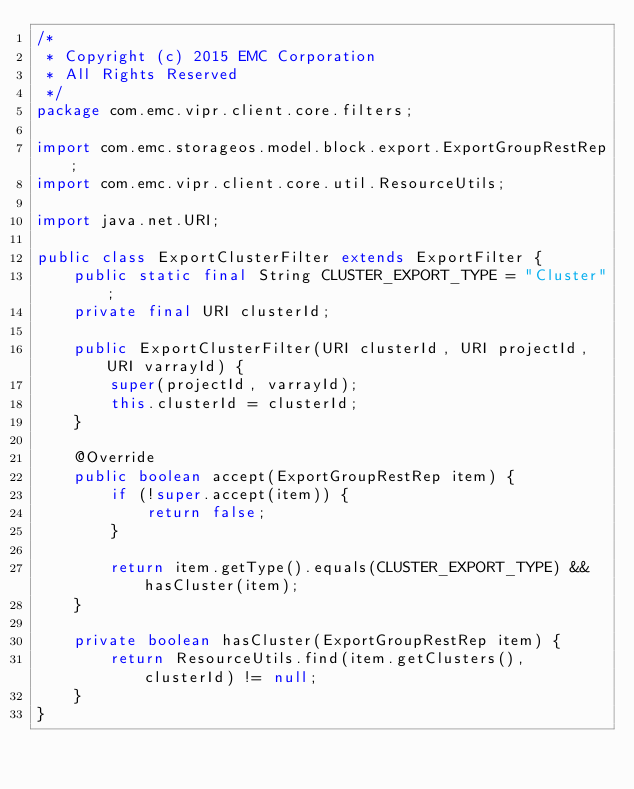Convert code to text. <code><loc_0><loc_0><loc_500><loc_500><_Java_>/*
 * Copyright (c) 2015 EMC Corporation
 * All Rights Reserved
 */
package com.emc.vipr.client.core.filters;

import com.emc.storageos.model.block.export.ExportGroupRestRep;
import com.emc.vipr.client.core.util.ResourceUtils;

import java.net.URI;

public class ExportClusterFilter extends ExportFilter {
    public static final String CLUSTER_EXPORT_TYPE = "Cluster";
    private final URI clusterId;

    public ExportClusterFilter(URI clusterId, URI projectId, URI varrayId) {
        super(projectId, varrayId);
        this.clusterId = clusterId;
    }

    @Override
    public boolean accept(ExportGroupRestRep item) {
        if (!super.accept(item)) {
            return false;
        }

        return item.getType().equals(CLUSTER_EXPORT_TYPE) && hasCluster(item);
    }

    private boolean hasCluster(ExportGroupRestRep item) {
        return ResourceUtils.find(item.getClusters(), clusterId) != null;
    }
}
</code> 